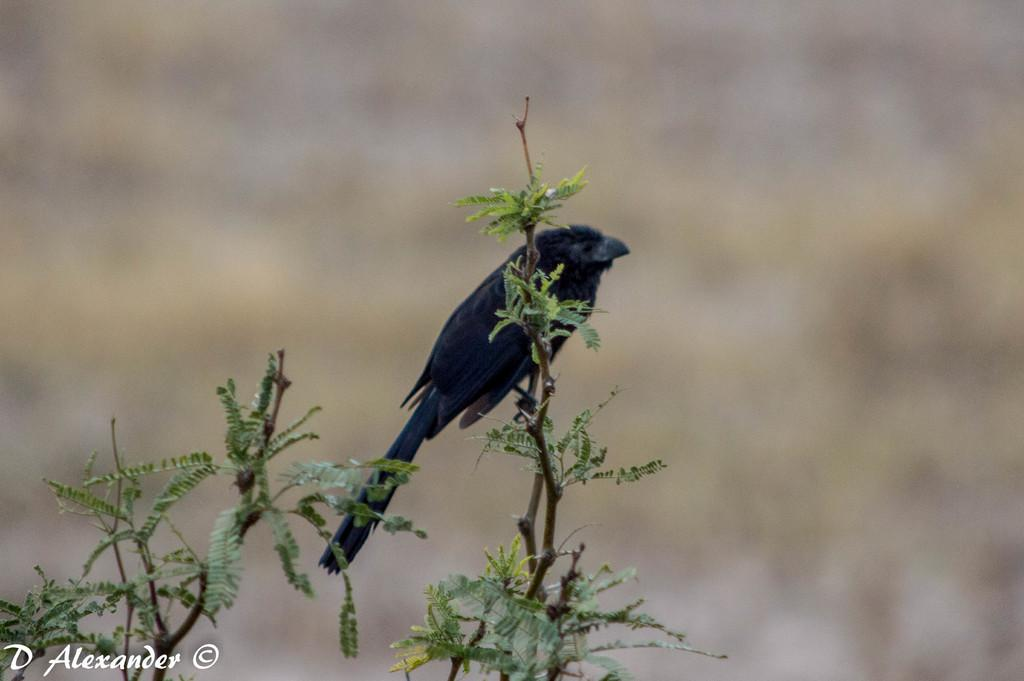What type of animal can be seen in the image? There is a bird in the image. Where is the bird located in the image? The bird is standing on a stem of a plant. What can be seen on the stem besides the bird? There are leaves on the stem. How would you describe the background of the image? The background of the image is blurry. What is present in the bottom left corner of the image? There is text in the bottom left corner of the image. What type of lock is holding the bird in the image? There is no lock present in the image; the bird is standing on a stem of a plant. 